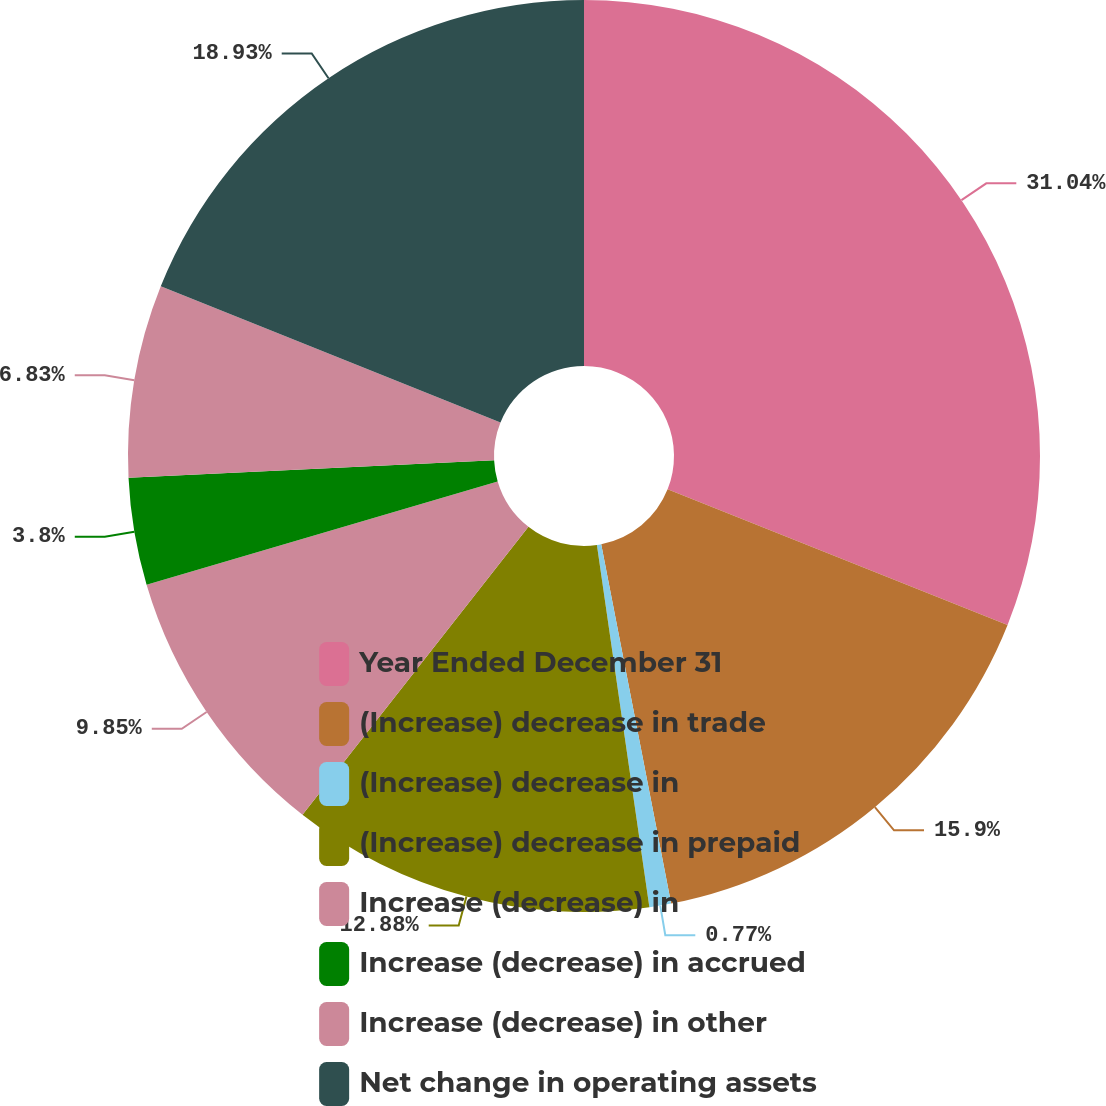Convert chart. <chart><loc_0><loc_0><loc_500><loc_500><pie_chart><fcel>Year Ended December 31<fcel>(Increase) decrease in trade<fcel>(Increase) decrease in<fcel>(Increase) decrease in prepaid<fcel>Increase (decrease) in<fcel>Increase (decrease) in accrued<fcel>Increase (decrease) in other<fcel>Net change in operating assets<nl><fcel>31.04%<fcel>15.9%<fcel>0.77%<fcel>12.88%<fcel>9.85%<fcel>3.8%<fcel>6.83%<fcel>18.93%<nl></chart> 